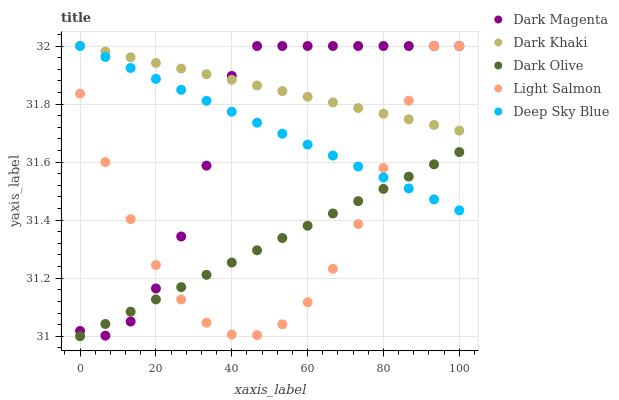Does Dark Olive have the minimum area under the curve?
Answer yes or no. Yes. Does Dark Khaki have the maximum area under the curve?
Answer yes or no. Yes. Does Light Salmon have the minimum area under the curve?
Answer yes or no. No. Does Light Salmon have the maximum area under the curve?
Answer yes or no. No. Is Dark Khaki the smoothest?
Answer yes or no. Yes. Is Light Salmon the roughest?
Answer yes or no. Yes. Is Dark Olive the smoothest?
Answer yes or no. No. Is Dark Olive the roughest?
Answer yes or no. No. Does Dark Olive have the lowest value?
Answer yes or no. Yes. Does Light Salmon have the lowest value?
Answer yes or no. No. Does Deep Sky Blue have the highest value?
Answer yes or no. Yes. Does Dark Olive have the highest value?
Answer yes or no. No. Is Dark Olive less than Dark Khaki?
Answer yes or no. Yes. Is Dark Khaki greater than Dark Olive?
Answer yes or no. Yes. Does Deep Sky Blue intersect Dark Magenta?
Answer yes or no. Yes. Is Deep Sky Blue less than Dark Magenta?
Answer yes or no. No. Is Deep Sky Blue greater than Dark Magenta?
Answer yes or no. No. Does Dark Olive intersect Dark Khaki?
Answer yes or no. No. 